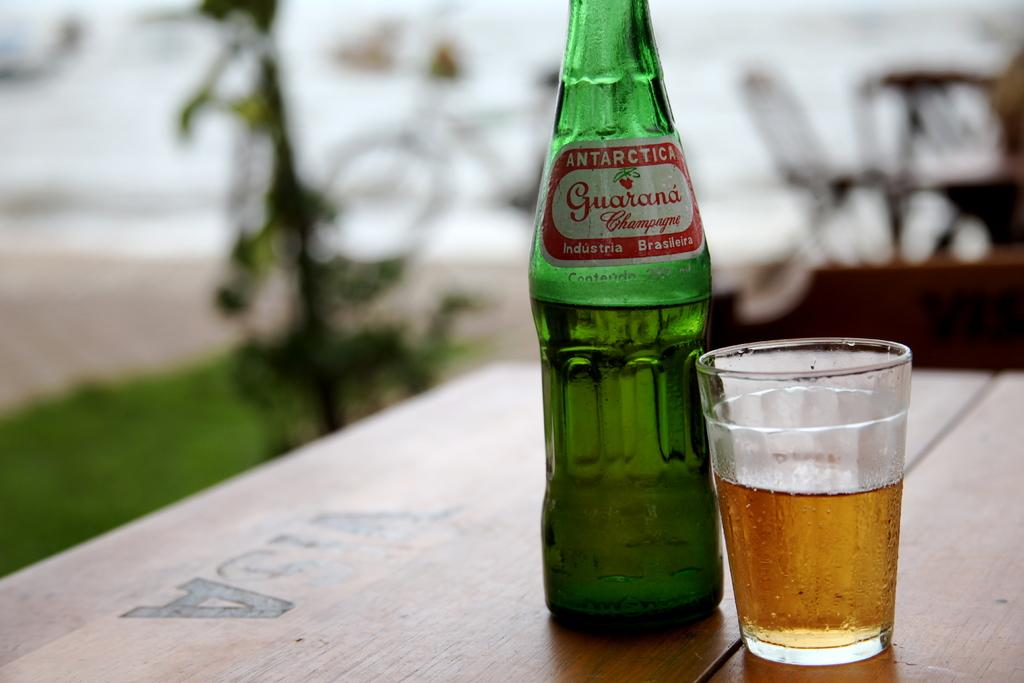What is present on the table in the image? There is a bottle and a glass on the table in the image. Can you describe the objects on the table? The objects on the table are a bottle and a glass. What type of camp can be seen in the background of the image? There is no camp present in the image; it only features a bottle and a glass on a table. What type of spark can be seen coming from the bottle in the image? There is no spark present in the image; it only features a bottle and a glass on a table. 